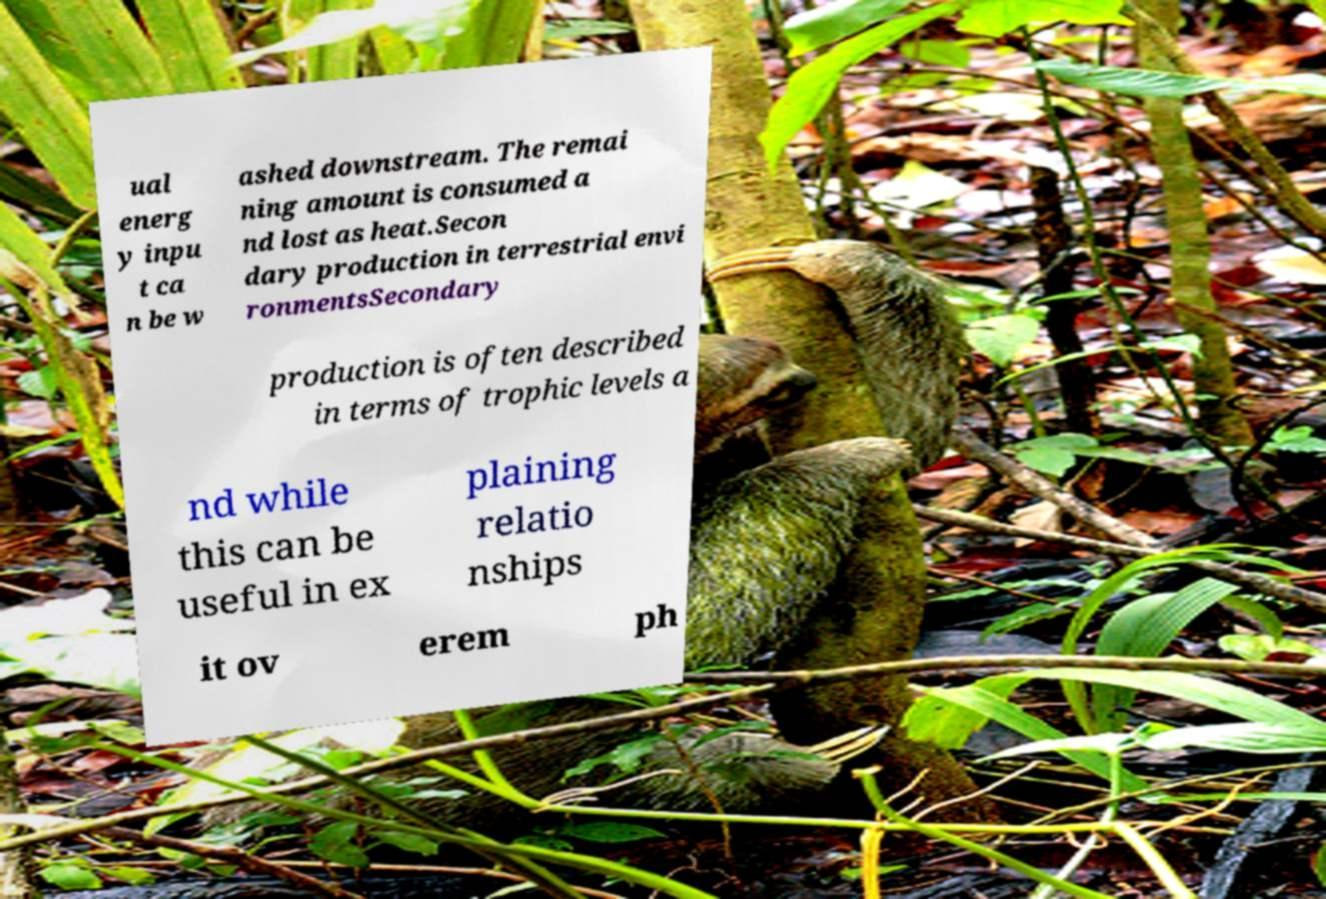Can you read and provide the text displayed in the image?This photo seems to have some interesting text. Can you extract and type it out for me? ual energ y inpu t ca n be w ashed downstream. The remai ning amount is consumed a nd lost as heat.Secon dary production in terrestrial envi ronmentsSecondary production is often described in terms of trophic levels a nd while this can be useful in ex plaining relatio nships it ov erem ph 